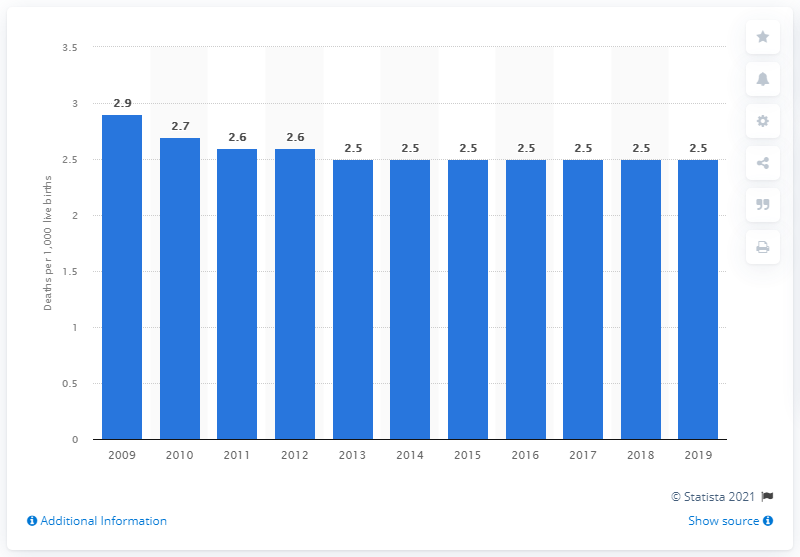Highlight a few significant elements in this photo. In 2019, the infant mortality rate in the Czech Republic was 2.5. 